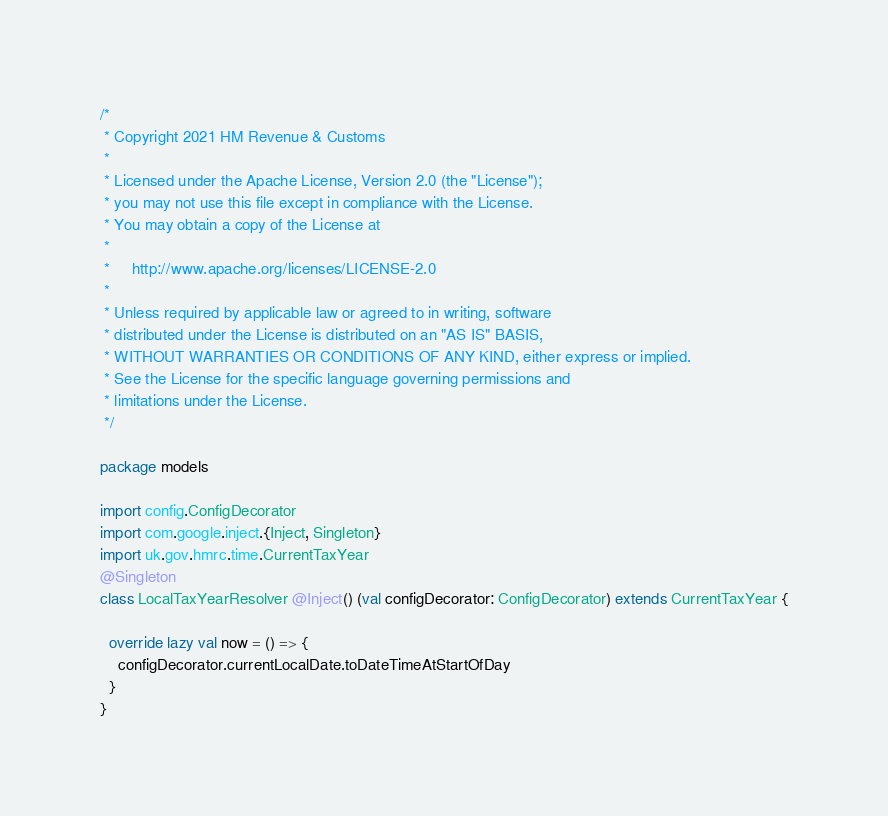<code> <loc_0><loc_0><loc_500><loc_500><_Scala_>/*
 * Copyright 2021 HM Revenue & Customs
 *
 * Licensed under the Apache License, Version 2.0 (the "License");
 * you may not use this file except in compliance with the License.
 * You may obtain a copy of the License at
 *
 *     http://www.apache.org/licenses/LICENSE-2.0
 *
 * Unless required by applicable law or agreed to in writing, software
 * distributed under the License is distributed on an "AS IS" BASIS,
 * WITHOUT WARRANTIES OR CONDITIONS OF ANY KIND, either express or implied.
 * See the License for the specific language governing permissions and
 * limitations under the License.
 */

package models

import config.ConfigDecorator
import com.google.inject.{Inject, Singleton}
import uk.gov.hmrc.time.CurrentTaxYear
@Singleton
class LocalTaxYearResolver @Inject() (val configDecorator: ConfigDecorator) extends CurrentTaxYear {

  override lazy val now = () => {
    configDecorator.currentLocalDate.toDateTimeAtStartOfDay
  }
}
</code> 